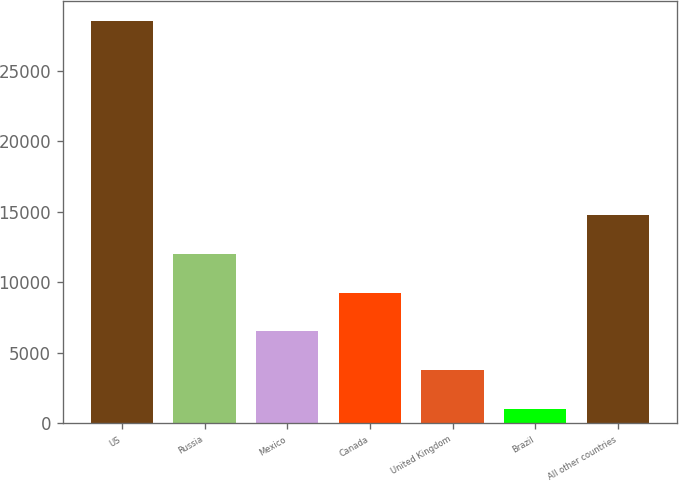Convert chart to OTSL. <chart><loc_0><loc_0><loc_500><loc_500><bar_chart><fcel>US<fcel>Russia<fcel>Mexico<fcel>Canada<fcel>United Kingdom<fcel>Brazil<fcel>All other countries<nl><fcel>28504<fcel>12005.2<fcel>6505.6<fcel>9255.4<fcel>3755.8<fcel>1006<fcel>14755<nl></chart> 